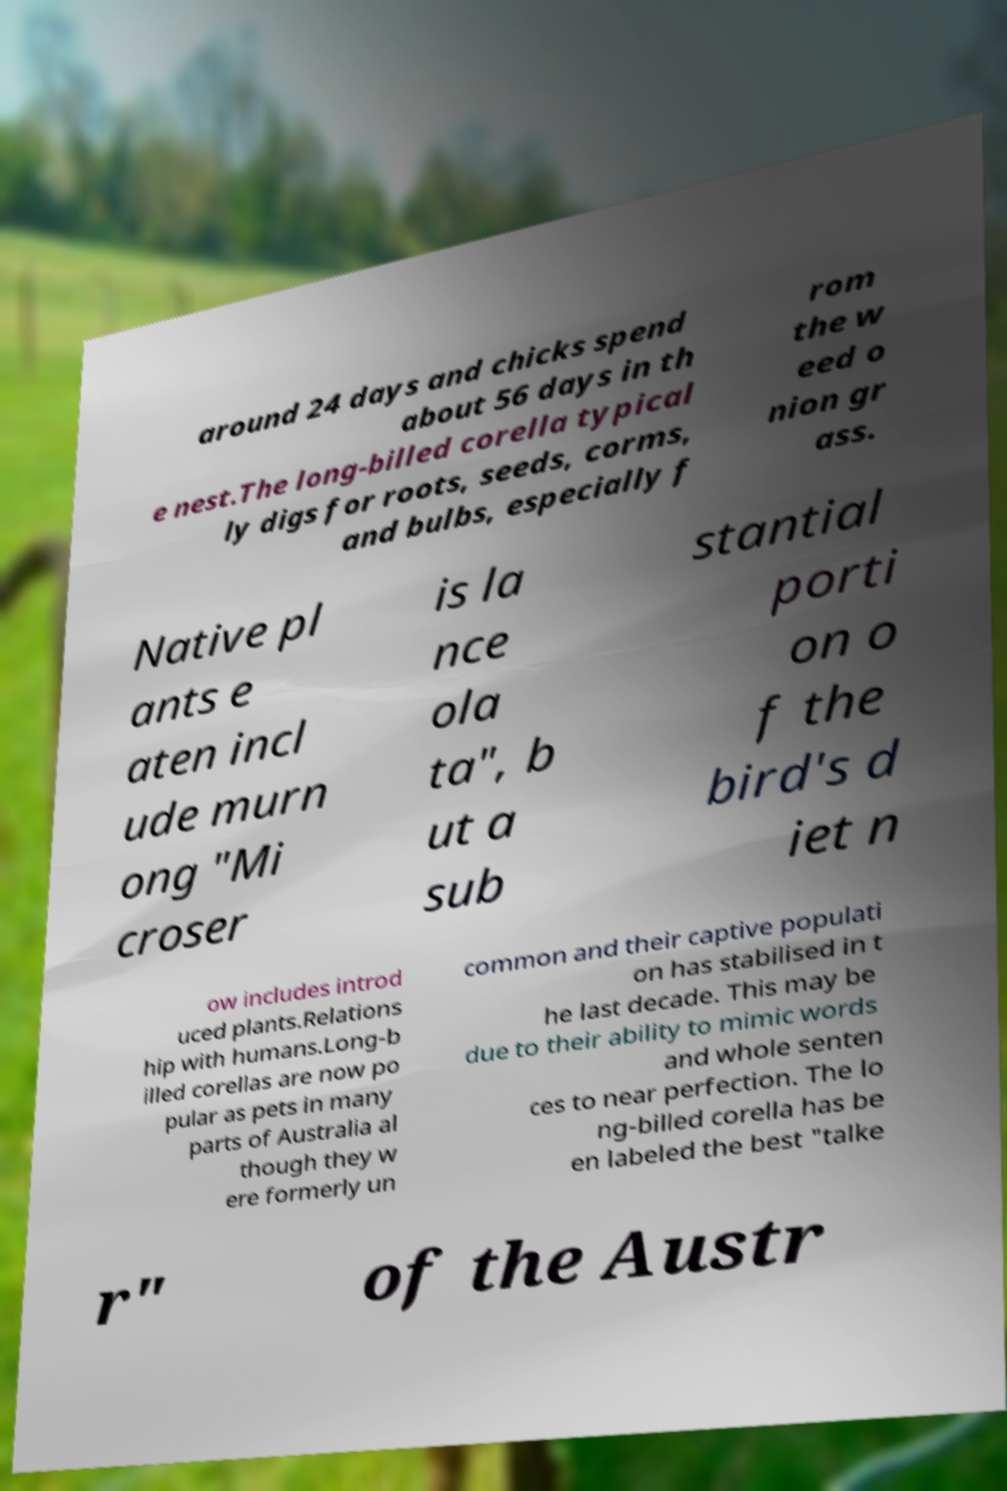Please identify and transcribe the text found in this image. around 24 days and chicks spend about 56 days in th e nest.The long-billed corella typical ly digs for roots, seeds, corms, and bulbs, especially f rom the w eed o nion gr ass. Native pl ants e aten incl ude murn ong "Mi croser is la nce ola ta", b ut a sub stantial porti on o f the bird's d iet n ow includes introd uced plants.Relations hip with humans.Long-b illed corellas are now po pular as pets in many parts of Australia al though they w ere formerly un common and their captive populati on has stabilised in t he last decade. This may be due to their ability to mimic words and whole senten ces to near perfection. The lo ng-billed corella has be en labeled the best "talke r" of the Austr 